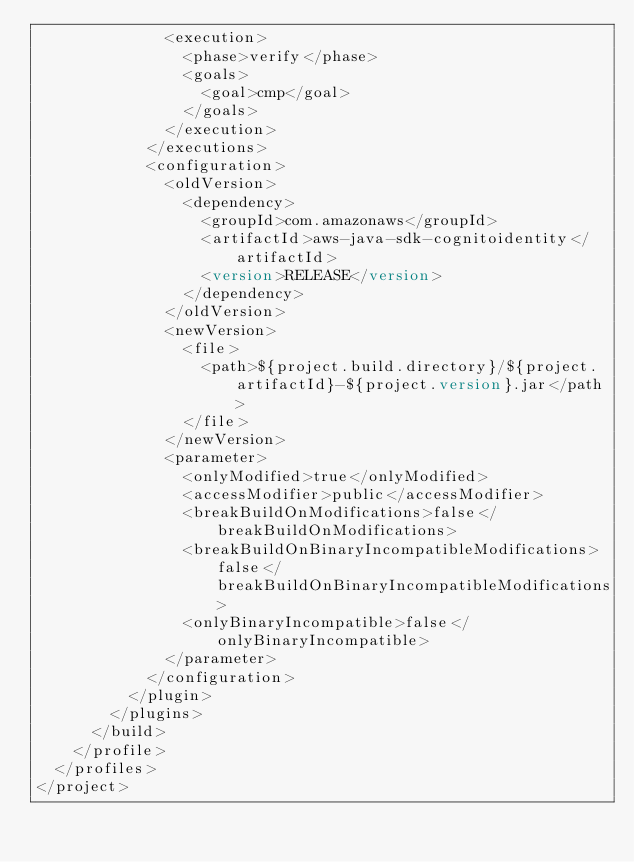<code> <loc_0><loc_0><loc_500><loc_500><_XML_>              <execution>
                <phase>verify</phase>
                <goals>
                  <goal>cmp</goal>
                </goals>
              </execution>
            </executions>
            <configuration>
              <oldVersion>
                <dependency>
                  <groupId>com.amazonaws</groupId>
                  <artifactId>aws-java-sdk-cognitoidentity</artifactId>
                  <version>RELEASE</version>
                </dependency>
              </oldVersion>
              <newVersion>
                <file>
                  <path>${project.build.directory}/${project.artifactId}-${project.version}.jar</path>
                </file>
              </newVersion>
              <parameter>
                <onlyModified>true</onlyModified>
                <accessModifier>public</accessModifier>
                <breakBuildOnModifications>false</breakBuildOnModifications>
                <breakBuildOnBinaryIncompatibleModifications>false</breakBuildOnBinaryIncompatibleModifications>
                <onlyBinaryIncompatible>false</onlyBinaryIncompatible>
              </parameter>
            </configuration>
          </plugin>
        </plugins>
      </build>
    </profile>
  </profiles>
</project>
</code> 